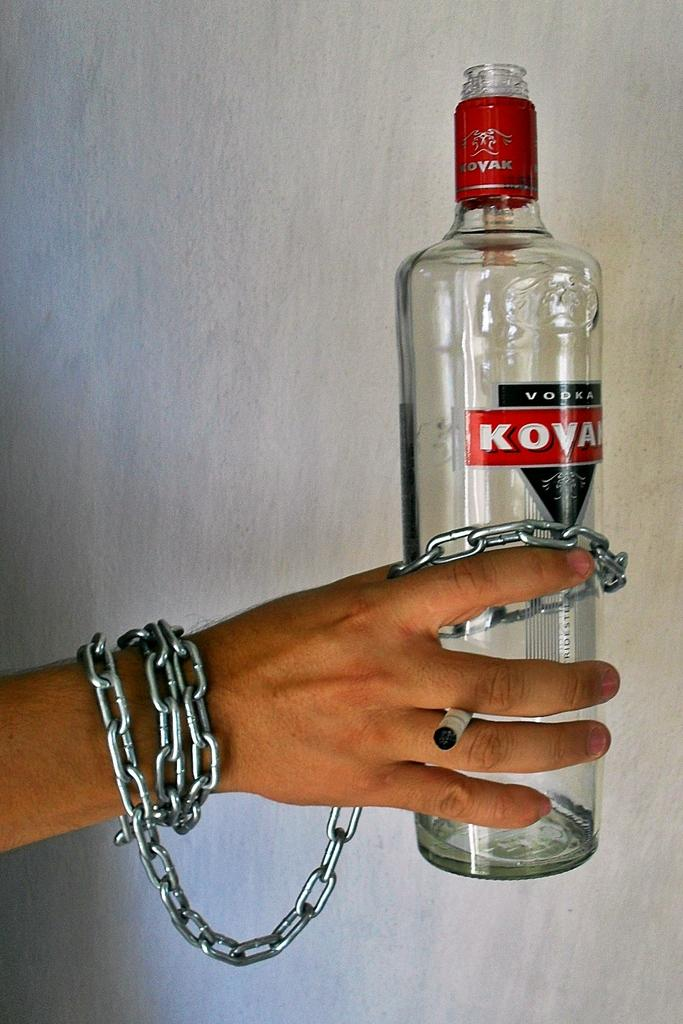<image>
Give a short and clear explanation of the subsequent image. the word koya that is on a bottle 